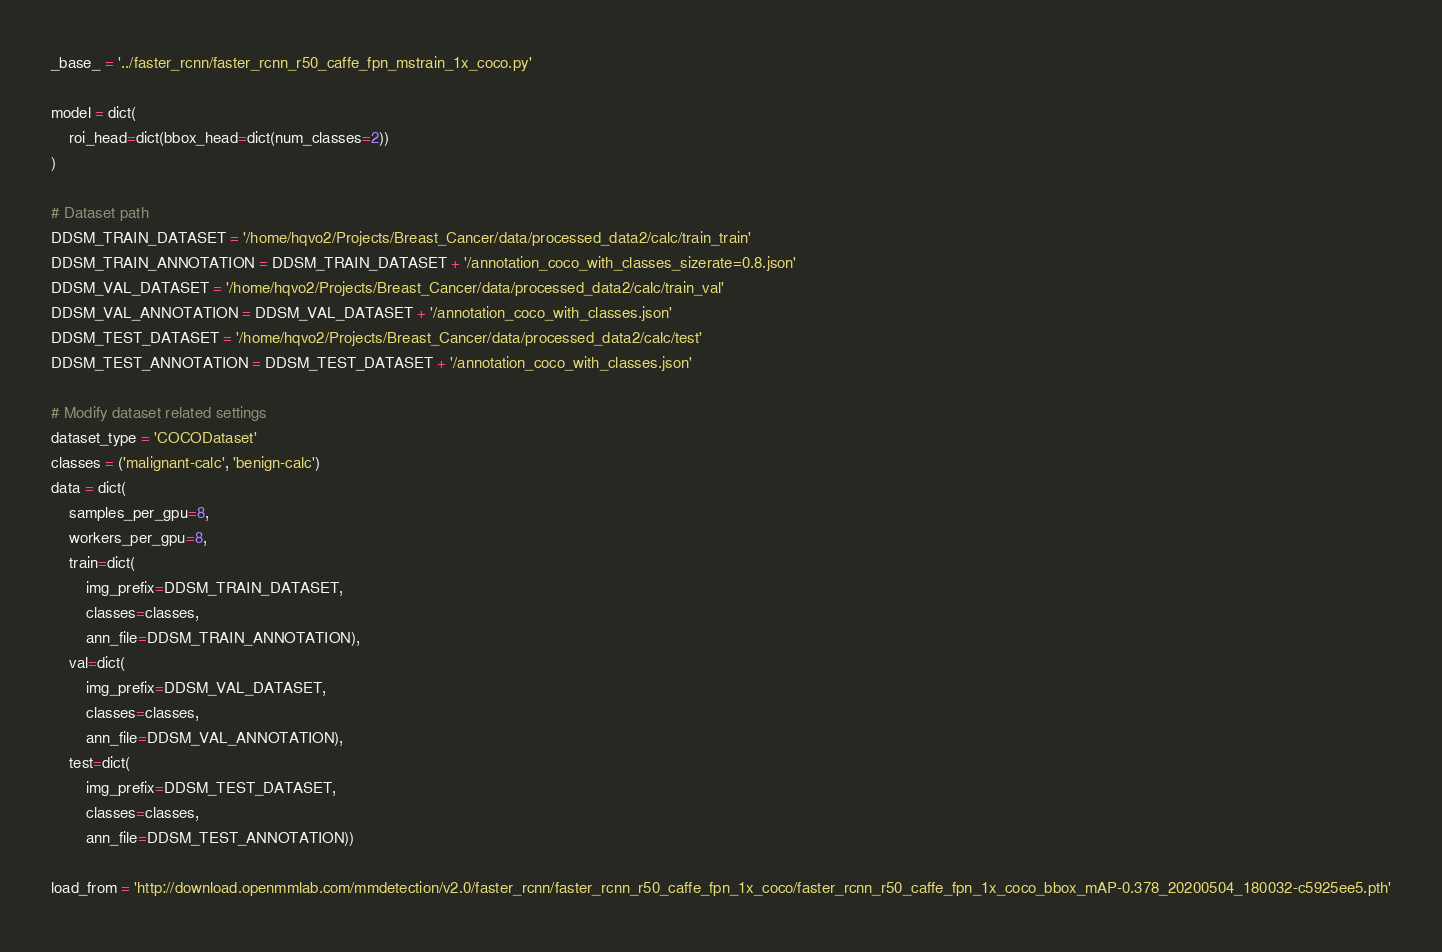Convert code to text. <code><loc_0><loc_0><loc_500><loc_500><_Python_>_base_ = '../faster_rcnn/faster_rcnn_r50_caffe_fpn_mstrain_1x_coco.py'

model = dict(
    roi_head=dict(bbox_head=dict(num_classes=2))
)

# Dataset path
DDSM_TRAIN_DATASET = '/home/hqvo2/Projects/Breast_Cancer/data/processed_data2/calc/train_train'
DDSM_TRAIN_ANNOTATION = DDSM_TRAIN_DATASET + '/annotation_coco_with_classes_sizerate=0.8.json'
DDSM_VAL_DATASET = '/home/hqvo2/Projects/Breast_Cancer/data/processed_data2/calc/train_val'
DDSM_VAL_ANNOTATION = DDSM_VAL_DATASET + '/annotation_coco_with_classes.json'
DDSM_TEST_DATASET = '/home/hqvo2/Projects/Breast_Cancer/data/processed_data2/calc/test'
DDSM_TEST_ANNOTATION = DDSM_TEST_DATASET + '/annotation_coco_with_classes.json'

# Modify dataset related settings
dataset_type = 'COCODataset'
classes = ('malignant-calc', 'benign-calc')
data = dict(
    samples_per_gpu=8,
    workers_per_gpu=8,
    train=dict(
        img_prefix=DDSM_TRAIN_DATASET,
        classes=classes,
        ann_file=DDSM_TRAIN_ANNOTATION),
    val=dict(
        img_prefix=DDSM_VAL_DATASET,
        classes=classes,
        ann_file=DDSM_VAL_ANNOTATION),
    test=dict(
        img_prefix=DDSM_TEST_DATASET,
        classes=classes,
        ann_file=DDSM_TEST_ANNOTATION))

load_from = 'http://download.openmmlab.com/mmdetection/v2.0/faster_rcnn/faster_rcnn_r50_caffe_fpn_1x_coco/faster_rcnn_r50_caffe_fpn_1x_coco_bbox_mAP-0.378_20200504_180032-c5925ee5.pth'</code> 